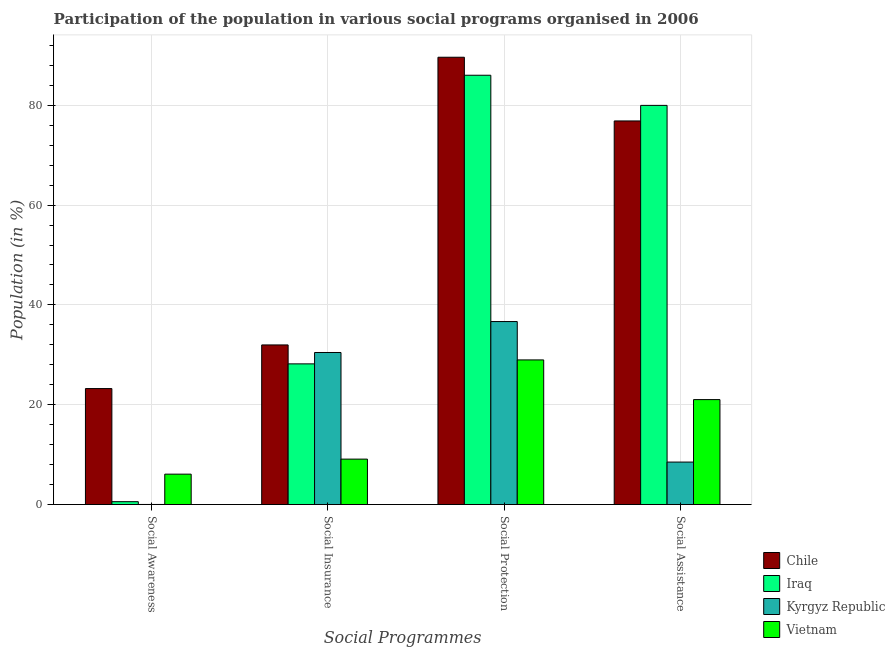How many different coloured bars are there?
Provide a short and direct response. 4. How many groups of bars are there?
Provide a short and direct response. 4. Are the number of bars on each tick of the X-axis equal?
Ensure brevity in your answer.  Yes. How many bars are there on the 3rd tick from the right?
Your response must be concise. 4. What is the label of the 3rd group of bars from the left?
Your answer should be compact. Social Protection. What is the participation of population in social protection programs in Kyrgyz Republic?
Your answer should be compact. 36.66. Across all countries, what is the maximum participation of population in social assistance programs?
Your response must be concise. 79.97. Across all countries, what is the minimum participation of population in social insurance programs?
Your response must be concise. 9.1. In which country was the participation of population in social protection programs maximum?
Ensure brevity in your answer.  Chile. In which country was the participation of population in social awareness programs minimum?
Provide a short and direct response. Kyrgyz Republic. What is the total participation of population in social insurance programs in the graph?
Give a very brief answer. 99.73. What is the difference between the participation of population in social assistance programs in Iraq and that in Chile?
Your answer should be very brief. 3.12. What is the difference between the participation of population in social protection programs in Chile and the participation of population in social assistance programs in Vietnam?
Offer a terse response. 68.59. What is the average participation of population in social awareness programs per country?
Provide a short and direct response. 7.48. What is the difference between the participation of population in social insurance programs and participation of population in social awareness programs in Chile?
Your response must be concise. 8.74. What is the ratio of the participation of population in social awareness programs in Kyrgyz Republic to that in Chile?
Make the answer very short. 0. What is the difference between the highest and the second highest participation of population in social insurance programs?
Give a very brief answer. 1.51. What is the difference between the highest and the lowest participation of population in social protection programs?
Provide a succinct answer. 60.64. In how many countries, is the participation of population in social insurance programs greater than the average participation of population in social insurance programs taken over all countries?
Your answer should be very brief. 3. Is the sum of the participation of population in social assistance programs in Iraq and Chile greater than the maximum participation of population in social insurance programs across all countries?
Your answer should be very brief. Yes. Is it the case that in every country, the sum of the participation of population in social protection programs and participation of population in social assistance programs is greater than the sum of participation of population in social insurance programs and participation of population in social awareness programs?
Offer a very short reply. No. What does the 1st bar from the left in Social Awareness represents?
Offer a very short reply. Chile. What does the 4th bar from the right in Social Awareness represents?
Make the answer very short. Chile. How many bars are there?
Your response must be concise. 16. Are all the bars in the graph horizontal?
Offer a very short reply. No. What is the difference between two consecutive major ticks on the Y-axis?
Provide a succinct answer. 20. Are the values on the major ticks of Y-axis written in scientific E-notation?
Ensure brevity in your answer.  No. Where does the legend appear in the graph?
Ensure brevity in your answer.  Bottom right. How many legend labels are there?
Your answer should be very brief. 4. What is the title of the graph?
Your answer should be compact. Participation of the population in various social programs organised in 2006. Does "Latin America(all income levels)" appear as one of the legend labels in the graph?
Offer a terse response. No. What is the label or title of the X-axis?
Give a very brief answer. Social Programmes. What is the Population (in %) in Chile in Social Awareness?
Provide a succinct answer. 23.24. What is the Population (in %) in Iraq in Social Awareness?
Keep it short and to the point. 0.57. What is the Population (in %) in Kyrgyz Republic in Social Awareness?
Provide a short and direct response. 0.02. What is the Population (in %) in Vietnam in Social Awareness?
Offer a very short reply. 6.09. What is the Population (in %) of Chile in Social Insurance?
Your answer should be very brief. 31.98. What is the Population (in %) in Iraq in Social Insurance?
Offer a very short reply. 28.19. What is the Population (in %) of Kyrgyz Republic in Social Insurance?
Offer a very short reply. 30.47. What is the Population (in %) in Vietnam in Social Insurance?
Ensure brevity in your answer.  9.1. What is the Population (in %) of Chile in Social Protection?
Ensure brevity in your answer.  89.62. What is the Population (in %) of Iraq in Social Protection?
Provide a succinct answer. 86.01. What is the Population (in %) in Kyrgyz Republic in Social Protection?
Keep it short and to the point. 36.66. What is the Population (in %) in Vietnam in Social Protection?
Ensure brevity in your answer.  28.98. What is the Population (in %) of Chile in Social Assistance?
Your answer should be compact. 76.86. What is the Population (in %) in Iraq in Social Assistance?
Offer a terse response. 79.97. What is the Population (in %) in Kyrgyz Republic in Social Assistance?
Provide a short and direct response. 8.51. What is the Population (in %) in Vietnam in Social Assistance?
Make the answer very short. 21.03. Across all Social Programmes, what is the maximum Population (in %) in Chile?
Ensure brevity in your answer.  89.62. Across all Social Programmes, what is the maximum Population (in %) of Iraq?
Your answer should be compact. 86.01. Across all Social Programmes, what is the maximum Population (in %) of Kyrgyz Republic?
Offer a terse response. 36.66. Across all Social Programmes, what is the maximum Population (in %) in Vietnam?
Provide a succinct answer. 28.98. Across all Social Programmes, what is the minimum Population (in %) in Chile?
Keep it short and to the point. 23.24. Across all Social Programmes, what is the minimum Population (in %) in Iraq?
Offer a very short reply. 0.57. Across all Social Programmes, what is the minimum Population (in %) of Kyrgyz Republic?
Give a very brief answer. 0.02. Across all Social Programmes, what is the minimum Population (in %) in Vietnam?
Provide a succinct answer. 6.09. What is the total Population (in %) of Chile in the graph?
Give a very brief answer. 221.69. What is the total Population (in %) in Iraq in the graph?
Your response must be concise. 194.75. What is the total Population (in %) of Kyrgyz Republic in the graph?
Make the answer very short. 75.66. What is the total Population (in %) in Vietnam in the graph?
Ensure brevity in your answer.  65.19. What is the difference between the Population (in %) in Chile in Social Awareness and that in Social Insurance?
Offer a terse response. -8.74. What is the difference between the Population (in %) in Iraq in Social Awareness and that in Social Insurance?
Offer a terse response. -27.61. What is the difference between the Population (in %) of Kyrgyz Republic in Social Awareness and that in Social Insurance?
Keep it short and to the point. -30.45. What is the difference between the Population (in %) of Vietnam in Social Awareness and that in Social Insurance?
Offer a very short reply. -3.01. What is the difference between the Population (in %) of Chile in Social Awareness and that in Social Protection?
Make the answer very short. -66.38. What is the difference between the Population (in %) of Iraq in Social Awareness and that in Social Protection?
Your response must be concise. -85.44. What is the difference between the Population (in %) of Kyrgyz Republic in Social Awareness and that in Social Protection?
Provide a short and direct response. -36.65. What is the difference between the Population (in %) of Vietnam in Social Awareness and that in Social Protection?
Your answer should be very brief. -22.89. What is the difference between the Population (in %) in Chile in Social Awareness and that in Social Assistance?
Your answer should be compact. -53.62. What is the difference between the Population (in %) of Iraq in Social Awareness and that in Social Assistance?
Provide a short and direct response. -79.4. What is the difference between the Population (in %) of Kyrgyz Republic in Social Awareness and that in Social Assistance?
Your answer should be compact. -8.5. What is the difference between the Population (in %) of Vietnam in Social Awareness and that in Social Assistance?
Give a very brief answer. -14.94. What is the difference between the Population (in %) of Chile in Social Insurance and that in Social Protection?
Your answer should be compact. -57.64. What is the difference between the Population (in %) of Iraq in Social Insurance and that in Social Protection?
Ensure brevity in your answer.  -57.83. What is the difference between the Population (in %) of Kyrgyz Republic in Social Insurance and that in Social Protection?
Keep it short and to the point. -6.2. What is the difference between the Population (in %) of Vietnam in Social Insurance and that in Social Protection?
Ensure brevity in your answer.  -19.88. What is the difference between the Population (in %) in Chile in Social Insurance and that in Social Assistance?
Offer a very short reply. -44.88. What is the difference between the Population (in %) in Iraq in Social Insurance and that in Social Assistance?
Provide a short and direct response. -51.79. What is the difference between the Population (in %) of Kyrgyz Republic in Social Insurance and that in Social Assistance?
Give a very brief answer. 21.96. What is the difference between the Population (in %) in Vietnam in Social Insurance and that in Social Assistance?
Give a very brief answer. -11.93. What is the difference between the Population (in %) of Chile in Social Protection and that in Social Assistance?
Keep it short and to the point. 12.76. What is the difference between the Population (in %) of Iraq in Social Protection and that in Social Assistance?
Offer a terse response. 6.04. What is the difference between the Population (in %) in Kyrgyz Republic in Social Protection and that in Social Assistance?
Your answer should be very brief. 28.15. What is the difference between the Population (in %) of Vietnam in Social Protection and that in Social Assistance?
Ensure brevity in your answer.  7.95. What is the difference between the Population (in %) in Chile in Social Awareness and the Population (in %) in Iraq in Social Insurance?
Make the answer very short. -4.95. What is the difference between the Population (in %) in Chile in Social Awareness and the Population (in %) in Kyrgyz Republic in Social Insurance?
Your response must be concise. -7.23. What is the difference between the Population (in %) in Chile in Social Awareness and the Population (in %) in Vietnam in Social Insurance?
Ensure brevity in your answer.  14.14. What is the difference between the Population (in %) in Iraq in Social Awareness and the Population (in %) in Kyrgyz Republic in Social Insurance?
Your response must be concise. -29.89. What is the difference between the Population (in %) of Iraq in Social Awareness and the Population (in %) of Vietnam in Social Insurance?
Your response must be concise. -8.53. What is the difference between the Population (in %) in Kyrgyz Republic in Social Awareness and the Population (in %) in Vietnam in Social Insurance?
Your answer should be compact. -9.08. What is the difference between the Population (in %) of Chile in Social Awareness and the Population (in %) of Iraq in Social Protection?
Offer a terse response. -62.78. What is the difference between the Population (in %) of Chile in Social Awareness and the Population (in %) of Kyrgyz Republic in Social Protection?
Provide a succinct answer. -13.43. What is the difference between the Population (in %) in Chile in Social Awareness and the Population (in %) in Vietnam in Social Protection?
Offer a terse response. -5.74. What is the difference between the Population (in %) in Iraq in Social Awareness and the Population (in %) in Kyrgyz Republic in Social Protection?
Make the answer very short. -36.09. What is the difference between the Population (in %) in Iraq in Social Awareness and the Population (in %) in Vietnam in Social Protection?
Give a very brief answer. -28.4. What is the difference between the Population (in %) in Kyrgyz Republic in Social Awareness and the Population (in %) in Vietnam in Social Protection?
Provide a short and direct response. -28.96. What is the difference between the Population (in %) in Chile in Social Awareness and the Population (in %) in Iraq in Social Assistance?
Ensure brevity in your answer.  -56.74. What is the difference between the Population (in %) in Chile in Social Awareness and the Population (in %) in Kyrgyz Republic in Social Assistance?
Make the answer very short. 14.73. What is the difference between the Population (in %) of Chile in Social Awareness and the Population (in %) of Vietnam in Social Assistance?
Offer a very short reply. 2.21. What is the difference between the Population (in %) in Iraq in Social Awareness and the Population (in %) in Kyrgyz Republic in Social Assistance?
Your response must be concise. -7.94. What is the difference between the Population (in %) of Iraq in Social Awareness and the Population (in %) of Vietnam in Social Assistance?
Your answer should be compact. -20.45. What is the difference between the Population (in %) in Kyrgyz Republic in Social Awareness and the Population (in %) in Vietnam in Social Assistance?
Your response must be concise. -21.01. What is the difference between the Population (in %) in Chile in Social Insurance and the Population (in %) in Iraq in Social Protection?
Offer a very short reply. -54.04. What is the difference between the Population (in %) in Chile in Social Insurance and the Population (in %) in Kyrgyz Republic in Social Protection?
Your answer should be very brief. -4.69. What is the difference between the Population (in %) of Chile in Social Insurance and the Population (in %) of Vietnam in Social Protection?
Your response must be concise. 3. What is the difference between the Population (in %) of Iraq in Social Insurance and the Population (in %) of Kyrgyz Republic in Social Protection?
Your answer should be very brief. -8.48. What is the difference between the Population (in %) of Iraq in Social Insurance and the Population (in %) of Vietnam in Social Protection?
Offer a terse response. -0.79. What is the difference between the Population (in %) in Kyrgyz Republic in Social Insurance and the Population (in %) in Vietnam in Social Protection?
Offer a very short reply. 1.49. What is the difference between the Population (in %) in Chile in Social Insurance and the Population (in %) in Iraq in Social Assistance?
Offer a very short reply. -48. What is the difference between the Population (in %) of Chile in Social Insurance and the Population (in %) of Kyrgyz Republic in Social Assistance?
Give a very brief answer. 23.47. What is the difference between the Population (in %) of Chile in Social Insurance and the Population (in %) of Vietnam in Social Assistance?
Your answer should be very brief. 10.95. What is the difference between the Population (in %) in Iraq in Social Insurance and the Population (in %) in Kyrgyz Republic in Social Assistance?
Your answer should be compact. 19.68. What is the difference between the Population (in %) of Iraq in Social Insurance and the Population (in %) of Vietnam in Social Assistance?
Offer a terse response. 7.16. What is the difference between the Population (in %) in Kyrgyz Republic in Social Insurance and the Population (in %) in Vietnam in Social Assistance?
Offer a very short reply. 9.44. What is the difference between the Population (in %) of Chile in Social Protection and the Population (in %) of Iraq in Social Assistance?
Keep it short and to the point. 9.65. What is the difference between the Population (in %) of Chile in Social Protection and the Population (in %) of Kyrgyz Republic in Social Assistance?
Offer a terse response. 81.11. What is the difference between the Population (in %) in Chile in Social Protection and the Population (in %) in Vietnam in Social Assistance?
Provide a succinct answer. 68.59. What is the difference between the Population (in %) in Iraq in Social Protection and the Population (in %) in Kyrgyz Republic in Social Assistance?
Make the answer very short. 77.5. What is the difference between the Population (in %) of Iraq in Social Protection and the Population (in %) of Vietnam in Social Assistance?
Provide a short and direct response. 64.99. What is the difference between the Population (in %) of Kyrgyz Republic in Social Protection and the Population (in %) of Vietnam in Social Assistance?
Your answer should be compact. 15.64. What is the average Population (in %) of Chile per Social Programmes?
Your answer should be very brief. 55.42. What is the average Population (in %) of Iraq per Social Programmes?
Keep it short and to the point. 48.69. What is the average Population (in %) of Kyrgyz Republic per Social Programmes?
Provide a succinct answer. 18.91. What is the average Population (in %) in Vietnam per Social Programmes?
Offer a terse response. 16.3. What is the difference between the Population (in %) of Chile and Population (in %) of Iraq in Social Awareness?
Your response must be concise. 22.67. What is the difference between the Population (in %) in Chile and Population (in %) in Kyrgyz Republic in Social Awareness?
Ensure brevity in your answer.  23.22. What is the difference between the Population (in %) in Chile and Population (in %) in Vietnam in Social Awareness?
Your answer should be compact. 17.15. What is the difference between the Population (in %) in Iraq and Population (in %) in Kyrgyz Republic in Social Awareness?
Provide a succinct answer. 0.56. What is the difference between the Population (in %) of Iraq and Population (in %) of Vietnam in Social Awareness?
Provide a short and direct response. -5.52. What is the difference between the Population (in %) in Kyrgyz Republic and Population (in %) in Vietnam in Social Awareness?
Your response must be concise. -6.07. What is the difference between the Population (in %) of Chile and Population (in %) of Iraq in Social Insurance?
Your answer should be compact. 3.79. What is the difference between the Population (in %) of Chile and Population (in %) of Kyrgyz Republic in Social Insurance?
Your response must be concise. 1.51. What is the difference between the Population (in %) in Chile and Population (in %) in Vietnam in Social Insurance?
Offer a very short reply. 22.88. What is the difference between the Population (in %) of Iraq and Population (in %) of Kyrgyz Republic in Social Insurance?
Provide a short and direct response. -2.28. What is the difference between the Population (in %) of Iraq and Population (in %) of Vietnam in Social Insurance?
Offer a very short reply. 19.09. What is the difference between the Population (in %) of Kyrgyz Republic and Population (in %) of Vietnam in Social Insurance?
Make the answer very short. 21.37. What is the difference between the Population (in %) in Chile and Population (in %) in Iraq in Social Protection?
Offer a terse response. 3.61. What is the difference between the Population (in %) in Chile and Population (in %) in Kyrgyz Republic in Social Protection?
Provide a succinct answer. 52.96. What is the difference between the Population (in %) in Chile and Population (in %) in Vietnam in Social Protection?
Give a very brief answer. 60.64. What is the difference between the Population (in %) in Iraq and Population (in %) in Kyrgyz Republic in Social Protection?
Provide a short and direct response. 49.35. What is the difference between the Population (in %) of Iraq and Population (in %) of Vietnam in Social Protection?
Keep it short and to the point. 57.04. What is the difference between the Population (in %) in Kyrgyz Republic and Population (in %) in Vietnam in Social Protection?
Your response must be concise. 7.69. What is the difference between the Population (in %) of Chile and Population (in %) of Iraq in Social Assistance?
Provide a succinct answer. -3.12. What is the difference between the Population (in %) of Chile and Population (in %) of Kyrgyz Republic in Social Assistance?
Provide a succinct answer. 68.35. What is the difference between the Population (in %) in Chile and Population (in %) in Vietnam in Social Assistance?
Give a very brief answer. 55.83. What is the difference between the Population (in %) of Iraq and Population (in %) of Kyrgyz Republic in Social Assistance?
Ensure brevity in your answer.  71.46. What is the difference between the Population (in %) in Iraq and Population (in %) in Vietnam in Social Assistance?
Make the answer very short. 58.95. What is the difference between the Population (in %) in Kyrgyz Republic and Population (in %) in Vietnam in Social Assistance?
Make the answer very short. -12.52. What is the ratio of the Population (in %) in Chile in Social Awareness to that in Social Insurance?
Your answer should be compact. 0.73. What is the ratio of the Population (in %) of Iraq in Social Awareness to that in Social Insurance?
Provide a succinct answer. 0.02. What is the ratio of the Population (in %) of Kyrgyz Republic in Social Awareness to that in Social Insurance?
Provide a short and direct response. 0. What is the ratio of the Population (in %) of Vietnam in Social Awareness to that in Social Insurance?
Ensure brevity in your answer.  0.67. What is the ratio of the Population (in %) of Chile in Social Awareness to that in Social Protection?
Ensure brevity in your answer.  0.26. What is the ratio of the Population (in %) in Iraq in Social Awareness to that in Social Protection?
Offer a terse response. 0.01. What is the ratio of the Population (in %) of Kyrgyz Republic in Social Awareness to that in Social Protection?
Provide a short and direct response. 0. What is the ratio of the Population (in %) in Vietnam in Social Awareness to that in Social Protection?
Make the answer very short. 0.21. What is the ratio of the Population (in %) in Chile in Social Awareness to that in Social Assistance?
Your answer should be compact. 0.3. What is the ratio of the Population (in %) of Iraq in Social Awareness to that in Social Assistance?
Provide a succinct answer. 0.01. What is the ratio of the Population (in %) in Kyrgyz Republic in Social Awareness to that in Social Assistance?
Your answer should be compact. 0. What is the ratio of the Population (in %) in Vietnam in Social Awareness to that in Social Assistance?
Give a very brief answer. 0.29. What is the ratio of the Population (in %) in Chile in Social Insurance to that in Social Protection?
Give a very brief answer. 0.36. What is the ratio of the Population (in %) in Iraq in Social Insurance to that in Social Protection?
Make the answer very short. 0.33. What is the ratio of the Population (in %) of Kyrgyz Republic in Social Insurance to that in Social Protection?
Ensure brevity in your answer.  0.83. What is the ratio of the Population (in %) in Vietnam in Social Insurance to that in Social Protection?
Your response must be concise. 0.31. What is the ratio of the Population (in %) of Chile in Social Insurance to that in Social Assistance?
Make the answer very short. 0.42. What is the ratio of the Population (in %) of Iraq in Social Insurance to that in Social Assistance?
Offer a terse response. 0.35. What is the ratio of the Population (in %) in Kyrgyz Republic in Social Insurance to that in Social Assistance?
Ensure brevity in your answer.  3.58. What is the ratio of the Population (in %) of Vietnam in Social Insurance to that in Social Assistance?
Your answer should be compact. 0.43. What is the ratio of the Population (in %) in Chile in Social Protection to that in Social Assistance?
Provide a short and direct response. 1.17. What is the ratio of the Population (in %) in Iraq in Social Protection to that in Social Assistance?
Your answer should be very brief. 1.08. What is the ratio of the Population (in %) of Kyrgyz Republic in Social Protection to that in Social Assistance?
Give a very brief answer. 4.31. What is the ratio of the Population (in %) of Vietnam in Social Protection to that in Social Assistance?
Provide a short and direct response. 1.38. What is the difference between the highest and the second highest Population (in %) of Chile?
Make the answer very short. 12.76. What is the difference between the highest and the second highest Population (in %) of Iraq?
Ensure brevity in your answer.  6.04. What is the difference between the highest and the second highest Population (in %) in Kyrgyz Republic?
Your response must be concise. 6.2. What is the difference between the highest and the second highest Population (in %) of Vietnam?
Your answer should be compact. 7.95. What is the difference between the highest and the lowest Population (in %) of Chile?
Offer a very short reply. 66.38. What is the difference between the highest and the lowest Population (in %) in Iraq?
Your answer should be compact. 85.44. What is the difference between the highest and the lowest Population (in %) in Kyrgyz Republic?
Your answer should be very brief. 36.65. What is the difference between the highest and the lowest Population (in %) of Vietnam?
Your answer should be very brief. 22.89. 